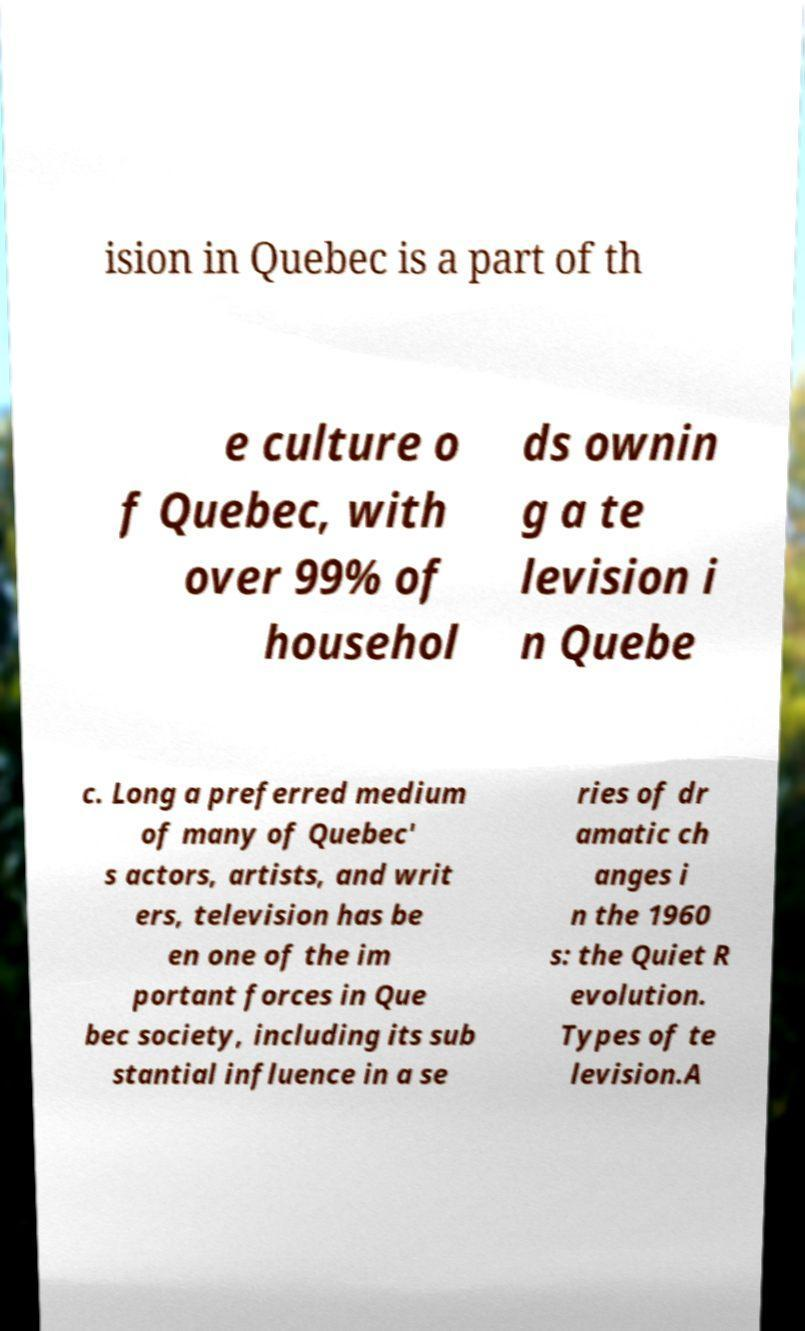There's text embedded in this image that I need extracted. Can you transcribe it verbatim? ision in Quebec is a part of th e culture o f Quebec, with over 99% of househol ds ownin g a te levision i n Quebe c. Long a preferred medium of many of Quebec' s actors, artists, and writ ers, television has be en one of the im portant forces in Que bec society, including its sub stantial influence in a se ries of dr amatic ch anges i n the 1960 s: the Quiet R evolution. Types of te levision.A 